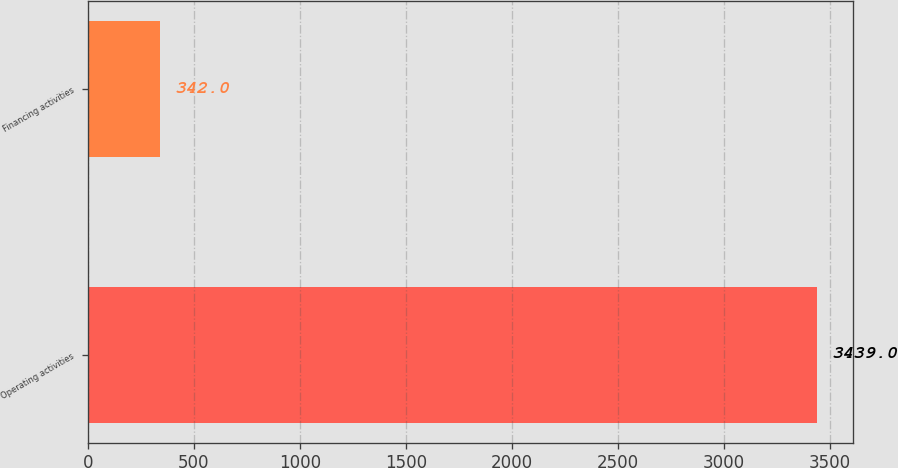Convert chart. <chart><loc_0><loc_0><loc_500><loc_500><bar_chart><fcel>Operating activities<fcel>Financing activities<nl><fcel>3439<fcel>342<nl></chart> 